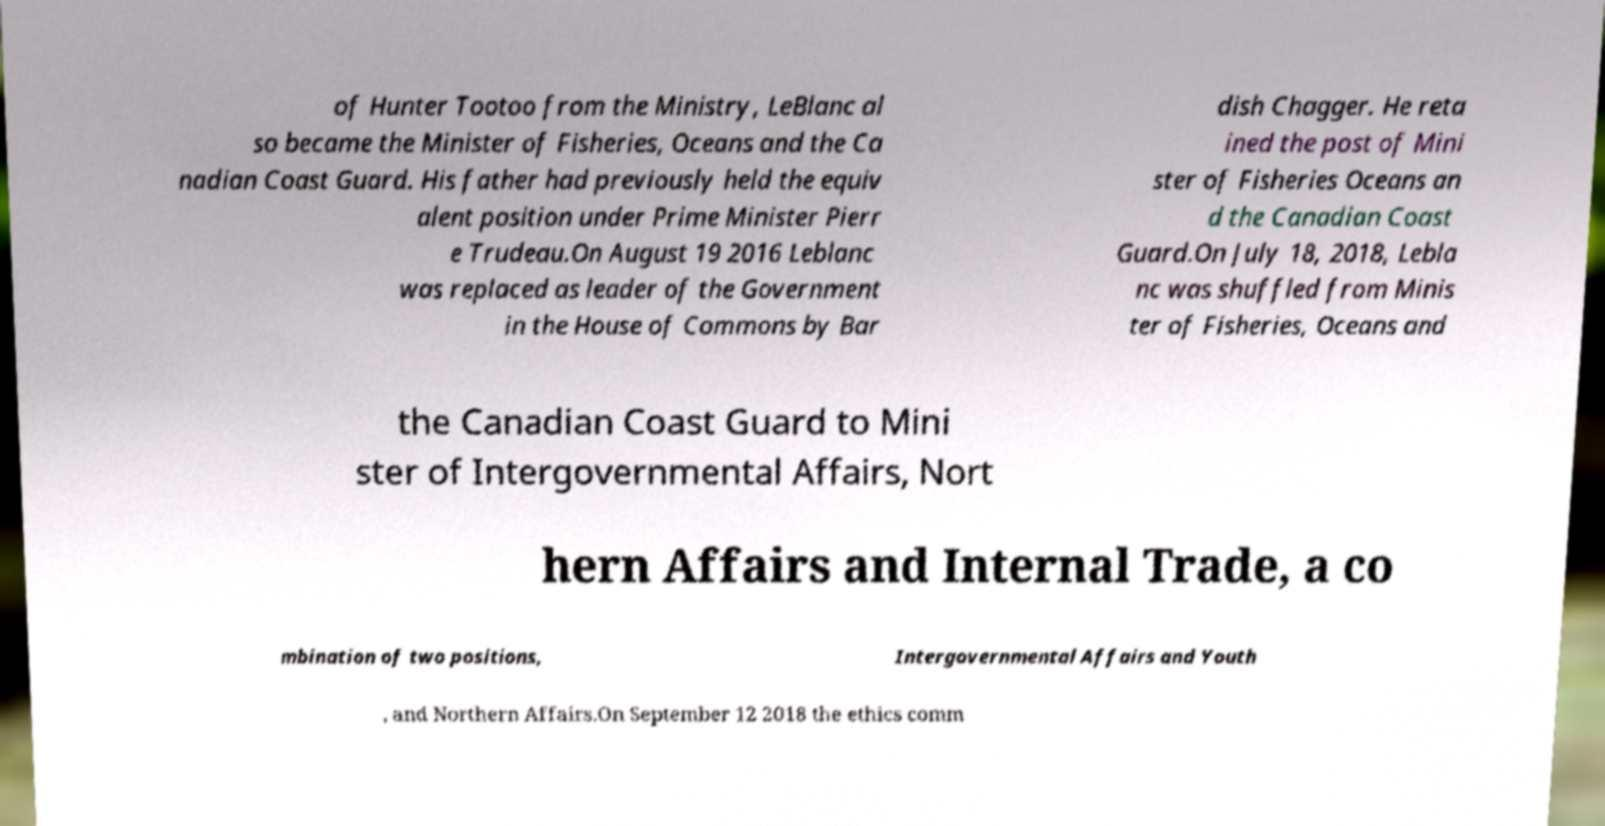For documentation purposes, I need the text within this image transcribed. Could you provide that? of Hunter Tootoo from the Ministry, LeBlanc al so became the Minister of Fisheries, Oceans and the Ca nadian Coast Guard. His father had previously held the equiv alent position under Prime Minister Pierr e Trudeau.On August 19 2016 Leblanc was replaced as leader of the Government in the House of Commons by Bar dish Chagger. He reta ined the post of Mini ster of Fisheries Oceans an d the Canadian Coast Guard.On July 18, 2018, Lebla nc was shuffled from Minis ter of Fisheries, Oceans and the Canadian Coast Guard to Mini ster of Intergovernmental Affairs, Nort hern Affairs and Internal Trade, a co mbination of two positions, Intergovernmental Affairs and Youth , and Northern Affairs.On September 12 2018 the ethics comm 